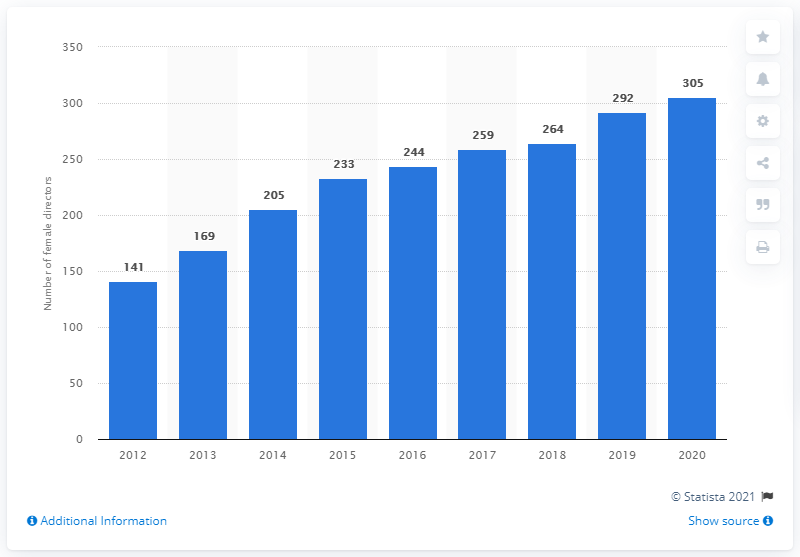Outline some significant characteristics in this image. As of June 2020, there were 305 female directors serving on the boards of FTSE 100 companies. As of June 2020, it was reported that there were 305 female directors serving on the boards of FTSE 100 companies. 